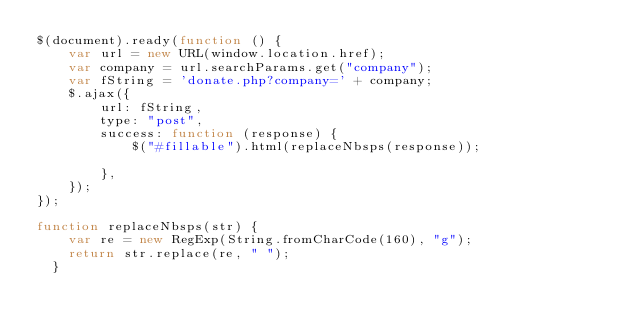<code> <loc_0><loc_0><loc_500><loc_500><_JavaScript_>$(document).ready(function () {
    var url = new URL(window.location.href);
    var company = url.searchParams.get("company");
    var fString = 'donate.php?company=' + company;
    $.ajax({
        url: fString,
        type: "post",
        success: function (response) {
            $("#fillable").html(replaceNbsps(response));
                     
        },
    });
});

function replaceNbsps(str) {
    var re = new RegExp(String.fromCharCode(160), "g");
    return str.replace(re, " ");
  }</code> 